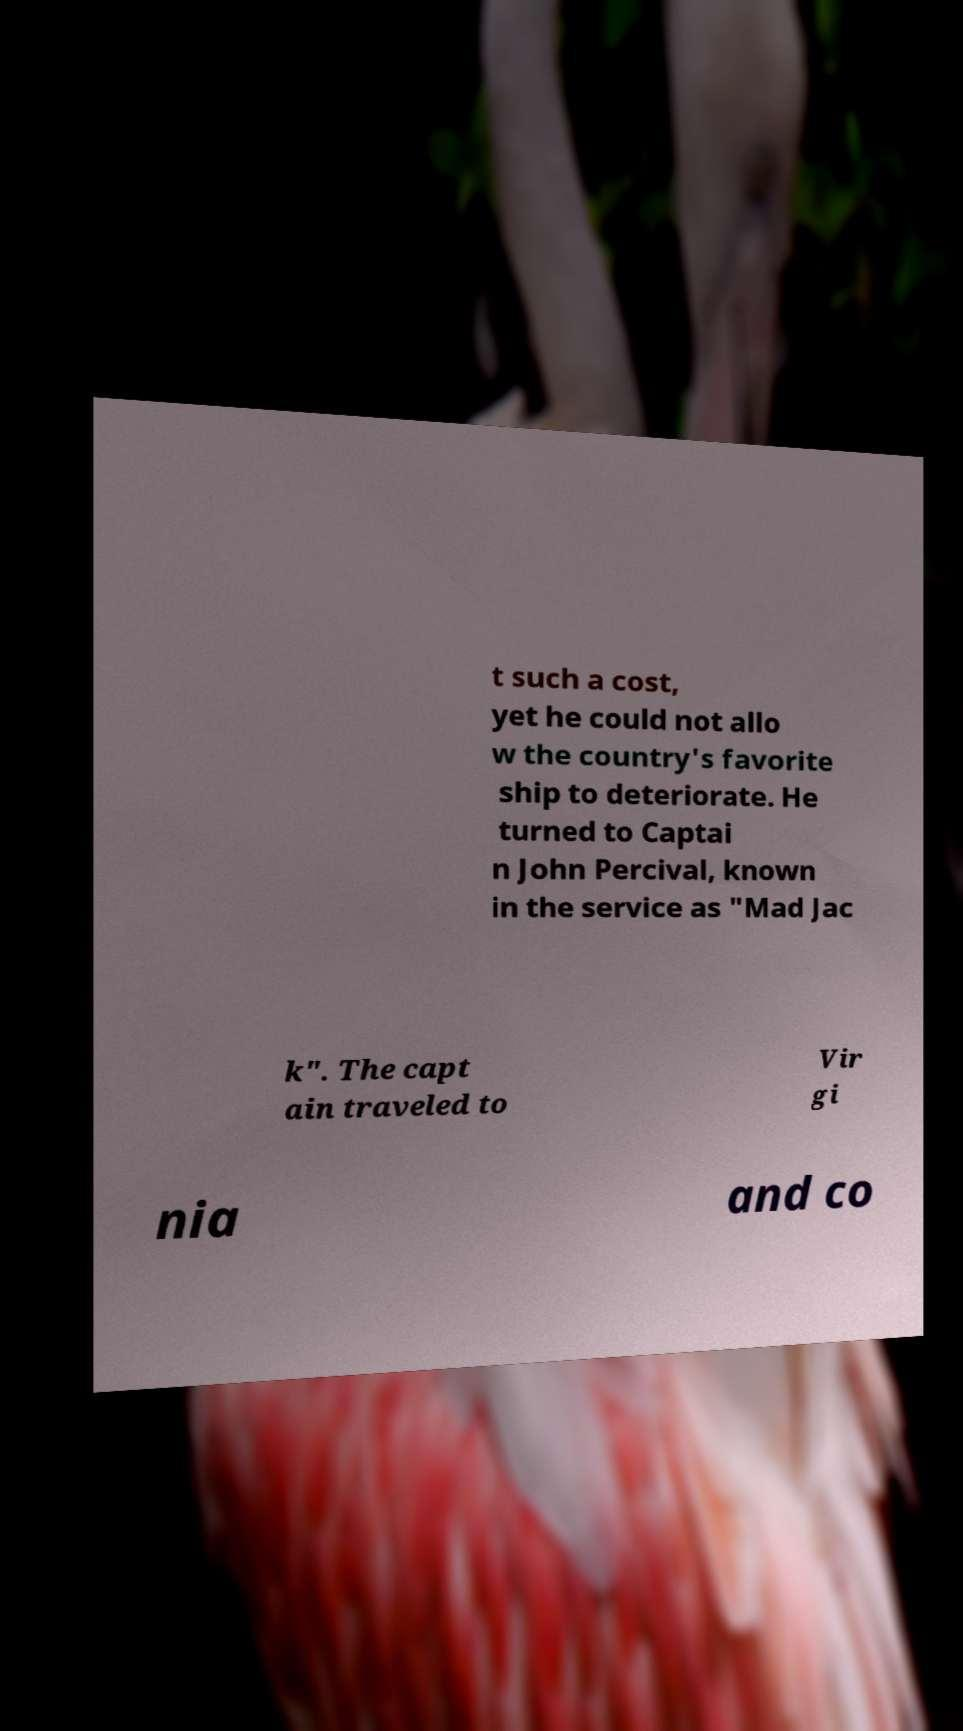For documentation purposes, I need the text within this image transcribed. Could you provide that? t such a cost, yet he could not allo w the country's favorite ship to deteriorate. He turned to Captai n John Percival, known in the service as "Mad Jac k". The capt ain traveled to Vir gi nia and co 